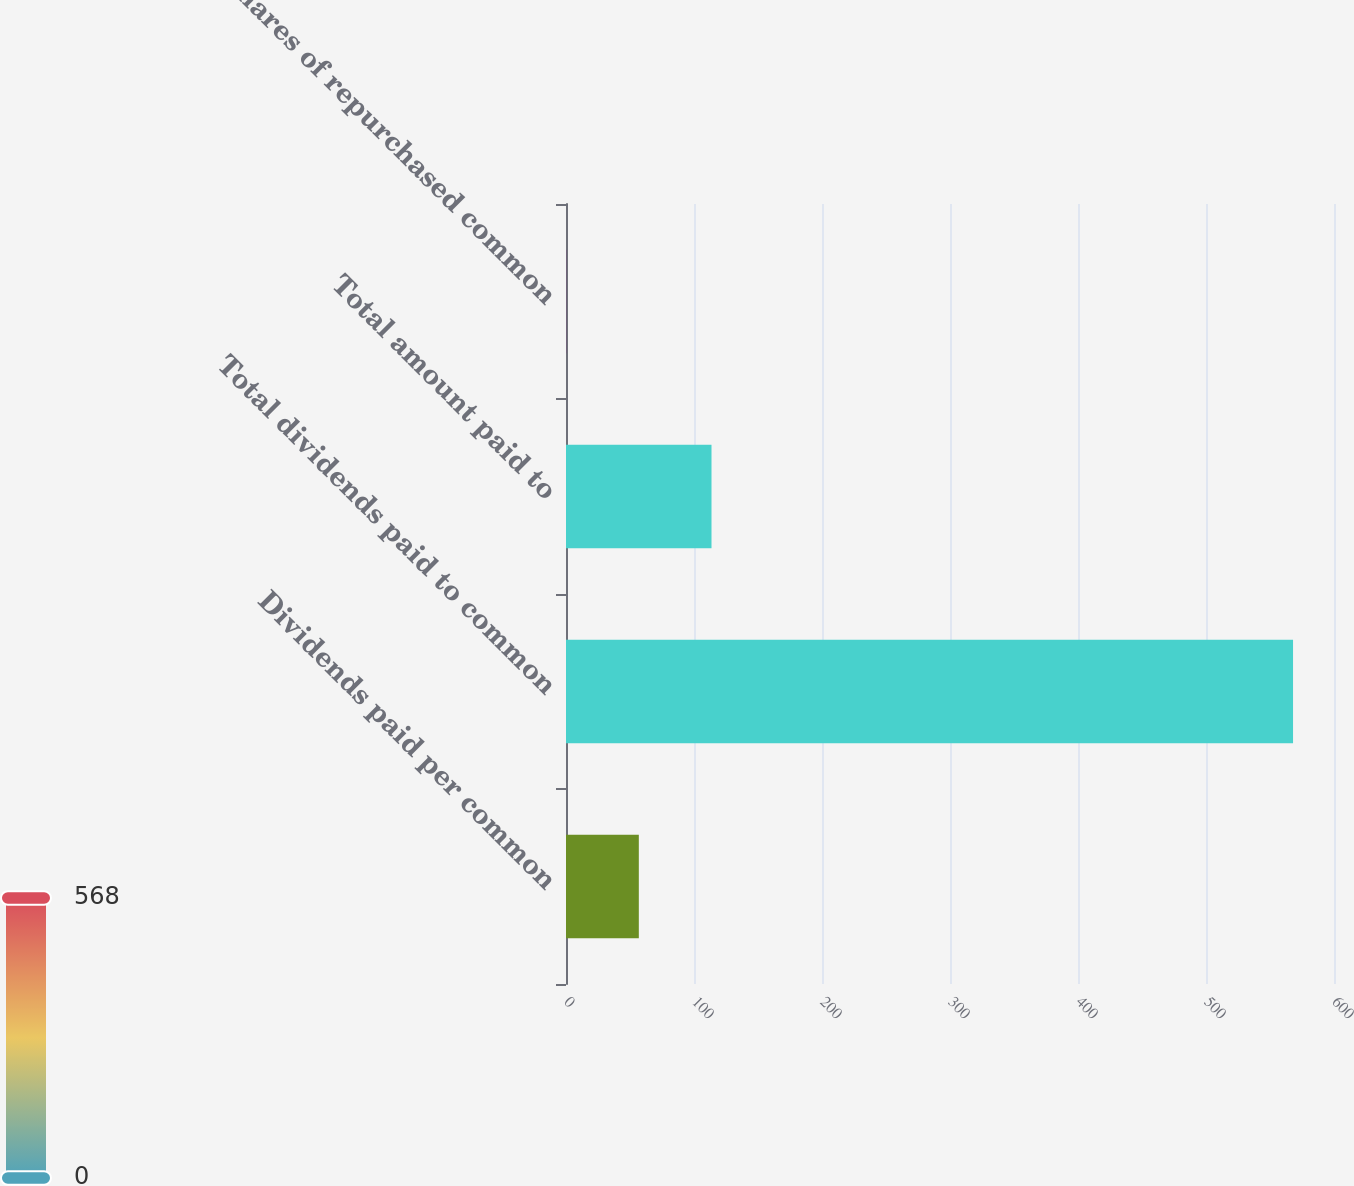Convert chart. <chart><loc_0><loc_0><loc_500><loc_500><bar_chart><fcel>Dividends paid per common<fcel>Total dividends paid to common<fcel>Total amount paid to<fcel>Shares of repurchased common<nl><fcel>56.89<fcel>568<fcel>113.68<fcel>0.1<nl></chart> 